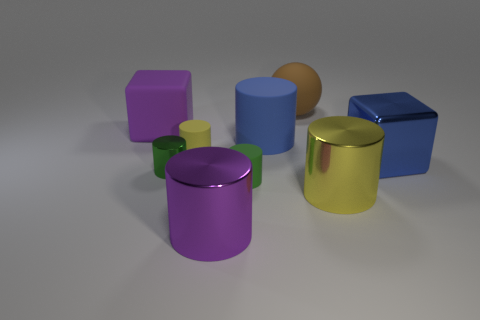Subtract all yellow cylinders. How many cylinders are left? 4 Add 1 blue rubber cylinders. How many objects exist? 10 Subtract all purple spheres. How many yellow cylinders are left? 2 Subtract all green cylinders. How many cylinders are left? 4 Subtract 2 cylinders. How many cylinders are left? 4 Subtract all spheres. How many objects are left? 8 Subtract all yellow metal cylinders. Subtract all large purple cylinders. How many objects are left? 7 Add 1 large brown things. How many large brown things are left? 2 Add 2 big red matte blocks. How many big red matte blocks exist? 2 Subtract 1 blue cylinders. How many objects are left? 8 